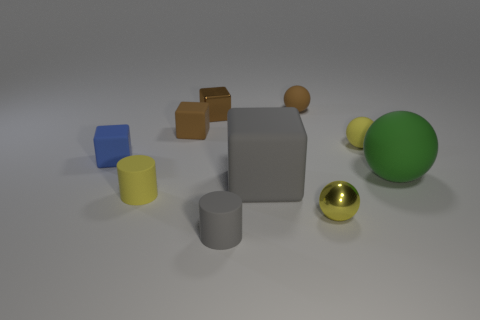Subtract all tiny balls. How many balls are left? 1 Subtract all green cylinders. How many brown cubes are left? 2 Subtract all blue cubes. How many cubes are left? 3 Subtract 2 cubes. How many cubes are left? 2 Subtract all cylinders. How many objects are left? 8 Subtract all purple balls. Subtract all red cubes. How many balls are left? 4 Subtract 0 red cylinders. How many objects are left? 10 Subtract all small yellow metallic spheres. Subtract all big gray matte things. How many objects are left? 8 Add 8 green objects. How many green objects are left? 9 Add 1 gray rubber blocks. How many gray rubber blocks exist? 2 